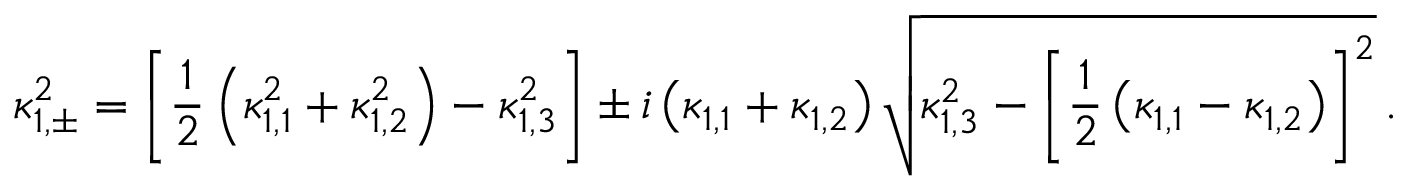Convert formula to latex. <formula><loc_0><loc_0><loc_500><loc_500>\kappa _ { 1 , \pm } ^ { 2 } = \left [ \frac { 1 } { 2 } \left ( \kappa _ { 1 , 1 } ^ { 2 } + \kappa _ { 1 , 2 } ^ { 2 } \right ) - \kappa _ { 1 , 3 } ^ { 2 } \right ] \pm i \left ( \kappa _ { 1 , 1 } + \kappa _ { 1 , 2 } \right ) \sqrt { \kappa _ { 1 , 3 } ^ { 2 } - \left [ \frac { 1 } { 2 } \left ( \kappa _ { 1 , 1 } - \kappa _ { 1 , 2 } \right ) \right ] ^ { 2 } } \, .</formula> 